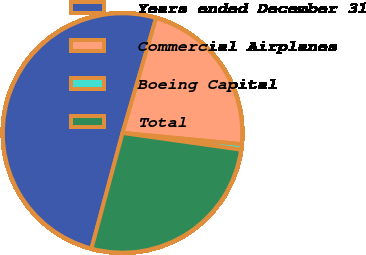Convert chart to OTSL. <chart><loc_0><loc_0><loc_500><loc_500><pie_chart><fcel>Years ended December 31<fcel>Commercial Airplanes<fcel>Boeing Capital<fcel>Total<nl><fcel>50.35%<fcel>21.98%<fcel>0.73%<fcel>26.95%<nl></chart> 